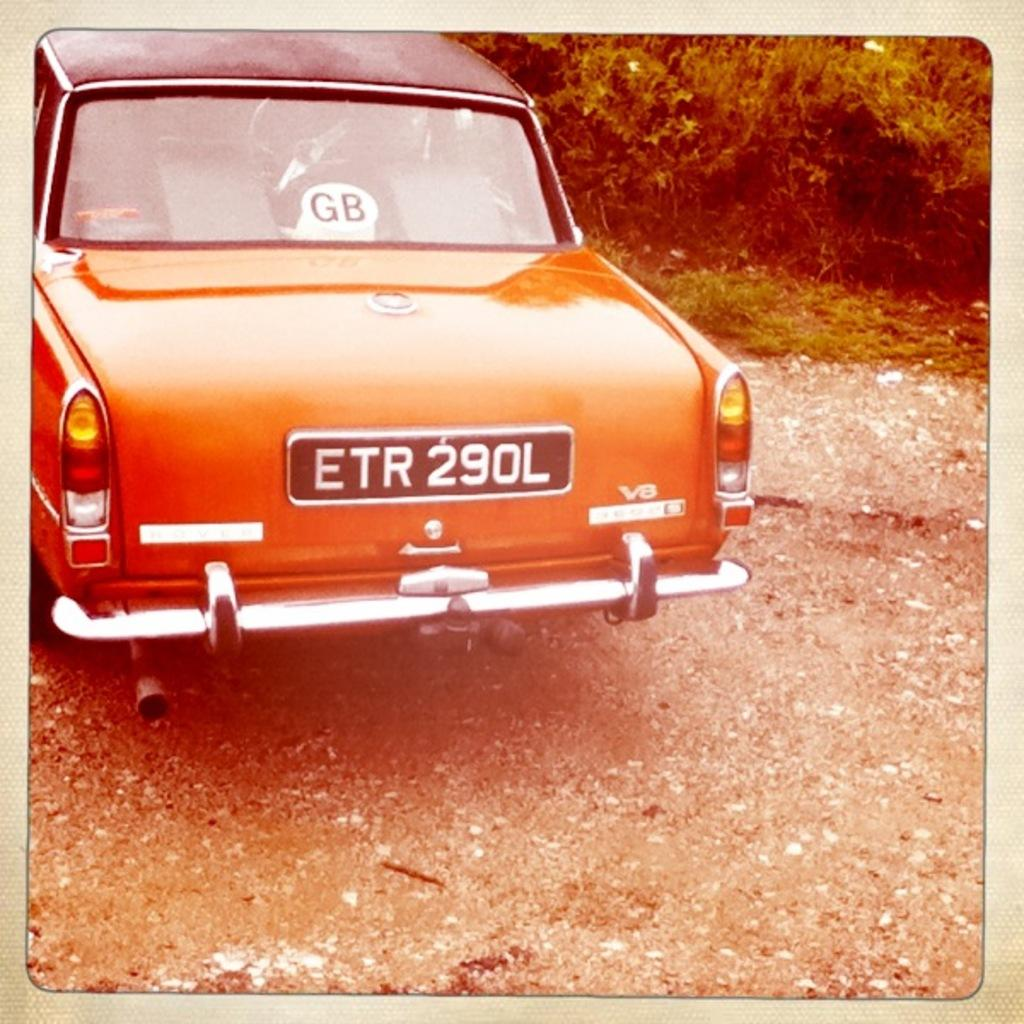What is located on the ground in the image? There is a car on the ground in the image. What can be seen in the background of the image? There are trees in the background of the image. What type of music is being played by the band in the image? There is no band present in the image, so it is not possible to determine what type of music might be played. 